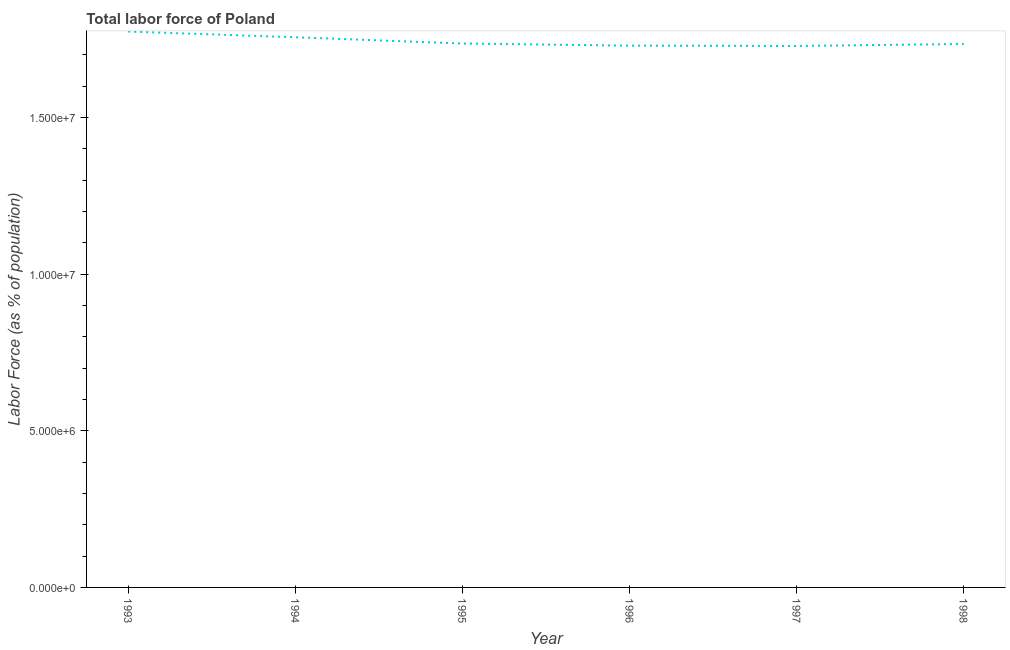What is the total labor force in 1998?
Your response must be concise. 1.73e+07. Across all years, what is the maximum total labor force?
Offer a very short reply. 1.77e+07. Across all years, what is the minimum total labor force?
Make the answer very short. 1.73e+07. What is the sum of the total labor force?
Make the answer very short. 1.05e+08. What is the difference between the total labor force in 1996 and 1997?
Offer a terse response. 1.04e+04. What is the average total labor force per year?
Your answer should be very brief. 1.74e+07. What is the median total labor force?
Offer a terse response. 1.74e+07. In how many years, is the total labor force greater than 2000000 %?
Your response must be concise. 6. What is the ratio of the total labor force in 1996 to that in 1998?
Ensure brevity in your answer.  1. Is the total labor force in 1993 less than that in 1997?
Provide a short and direct response. No. Is the difference between the total labor force in 1994 and 1996 greater than the difference between any two years?
Offer a very short reply. No. What is the difference between the highest and the second highest total labor force?
Provide a succinct answer. 1.82e+05. What is the difference between the highest and the lowest total labor force?
Offer a very short reply. 4.60e+05. In how many years, is the total labor force greater than the average total labor force taken over all years?
Keep it short and to the point. 2. Does the total labor force monotonically increase over the years?
Give a very brief answer. No. How many lines are there?
Offer a terse response. 1. How many years are there in the graph?
Your response must be concise. 6. Does the graph contain grids?
Provide a succinct answer. No. What is the title of the graph?
Your response must be concise. Total labor force of Poland. What is the label or title of the Y-axis?
Ensure brevity in your answer.  Labor Force (as % of population). What is the Labor Force (as % of population) in 1993?
Give a very brief answer. 1.77e+07. What is the Labor Force (as % of population) in 1994?
Your answer should be compact. 1.76e+07. What is the Labor Force (as % of population) of 1995?
Your answer should be compact. 1.74e+07. What is the Labor Force (as % of population) of 1996?
Your answer should be very brief. 1.73e+07. What is the Labor Force (as % of population) of 1997?
Keep it short and to the point. 1.73e+07. What is the Labor Force (as % of population) in 1998?
Give a very brief answer. 1.73e+07. What is the difference between the Labor Force (as % of population) in 1993 and 1994?
Keep it short and to the point. 1.82e+05. What is the difference between the Labor Force (as % of population) in 1993 and 1995?
Ensure brevity in your answer.  3.82e+05. What is the difference between the Labor Force (as % of population) in 1993 and 1996?
Keep it short and to the point. 4.50e+05. What is the difference between the Labor Force (as % of population) in 1993 and 1997?
Provide a succinct answer. 4.60e+05. What is the difference between the Labor Force (as % of population) in 1993 and 1998?
Offer a very short reply. 3.97e+05. What is the difference between the Labor Force (as % of population) in 1994 and 1995?
Give a very brief answer. 2.01e+05. What is the difference between the Labor Force (as % of population) in 1994 and 1996?
Provide a succinct answer. 2.68e+05. What is the difference between the Labor Force (as % of population) in 1994 and 1997?
Give a very brief answer. 2.79e+05. What is the difference between the Labor Force (as % of population) in 1994 and 1998?
Give a very brief answer. 2.16e+05. What is the difference between the Labor Force (as % of population) in 1995 and 1996?
Offer a very short reply. 6.77e+04. What is the difference between the Labor Force (as % of population) in 1995 and 1997?
Make the answer very short. 7.81e+04. What is the difference between the Labor Force (as % of population) in 1995 and 1998?
Give a very brief answer. 1.50e+04. What is the difference between the Labor Force (as % of population) in 1996 and 1997?
Your response must be concise. 1.04e+04. What is the difference between the Labor Force (as % of population) in 1996 and 1998?
Make the answer very short. -5.27e+04. What is the difference between the Labor Force (as % of population) in 1997 and 1998?
Give a very brief answer. -6.32e+04. What is the ratio of the Labor Force (as % of population) in 1993 to that in 1994?
Your answer should be very brief. 1.01. What is the ratio of the Labor Force (as % of population) in 1993 to that in 1997?
Provide a short and direct response. 1.03. What is the ratio of the Labor Force (as % of population) in 1994 to that in 1998?
Make the answer very short. 1.01. What is the ratio of the Labor Force (as % of population) in 1995 to that in 1996?
Keep it short and to the point. 1. What is the ratio of the Labor Force (as % of population) in 1995 to that in 1997?
Offer a very short reply. 1. What is the ratio of the Labor Force (as % of population) in 1995 to that in 1998?
Your answer should be compact. 1. What is the ratio of the Labor Force (as % of population) in 1996 to that in 1997?
Your answer should be very brief. 1. What is the ratio of the Labor Force (as % of population) in 1996 to that in 1998?
Ensure brevity in your answer.  1. 